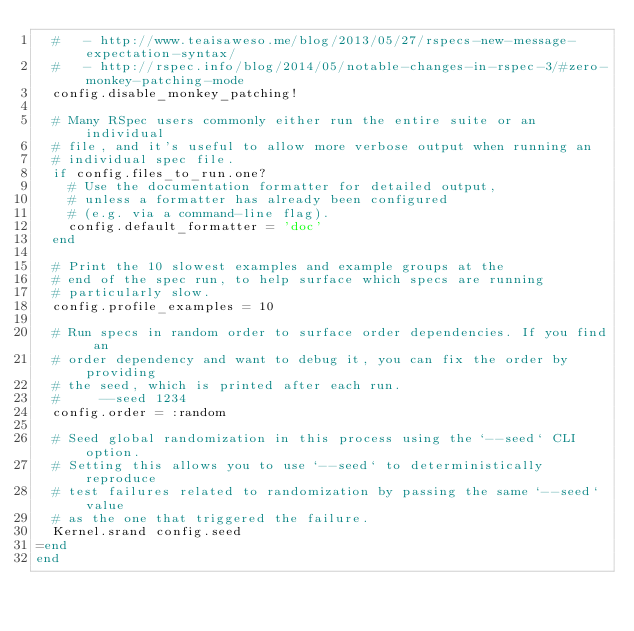Convert code to text. <code><loc_0><loc_0><loc_500><loc_500><_Ruby_>  #   - http://www.teaisaweso.me/blog/2013/05/27/rspecs-new-message-expectation-syntax/
  #   - http://rspec.info/blog/2014/05/notable-changes-in-rspec-3/#zero-monkey-patching-mode
  config.disable_monkey_patching!

  # Many RSpec users commonly either run the entire suite or an individual
  # file, and it's useful to allow more verbose output when running an
  # individual spec file.
  if config.files_to_run.one?
    # Use the documentation formatter for detailed output,
    # unless a formatter has already been configured
    # (e.g. via a command-line flag).
    config.default_formatter = 'doc'
  end

  # Print the 10 slowest examples and example groups at the
  # end of the spec run, to help surface which specs are running
  # particularly slow.
  config.profile_examples = 10

  # Run specs in random order to surface order dependencies. If you find an
  # order dependency and want to debug it, you can fix the order by providing
  # the seed, which is printed after each run.
  #     --seed 1234
  config.order = :random

  # Seed global randomization in this process using the `--seed` CLI option.
  # Setting this allows you to use `--seed` to deterministically reproduce
  # test failures related to randomization by passing the same `--seed` value
  # as the one that triggered the failure.
  Kernel.srand config.seed
=end
end
</code> 